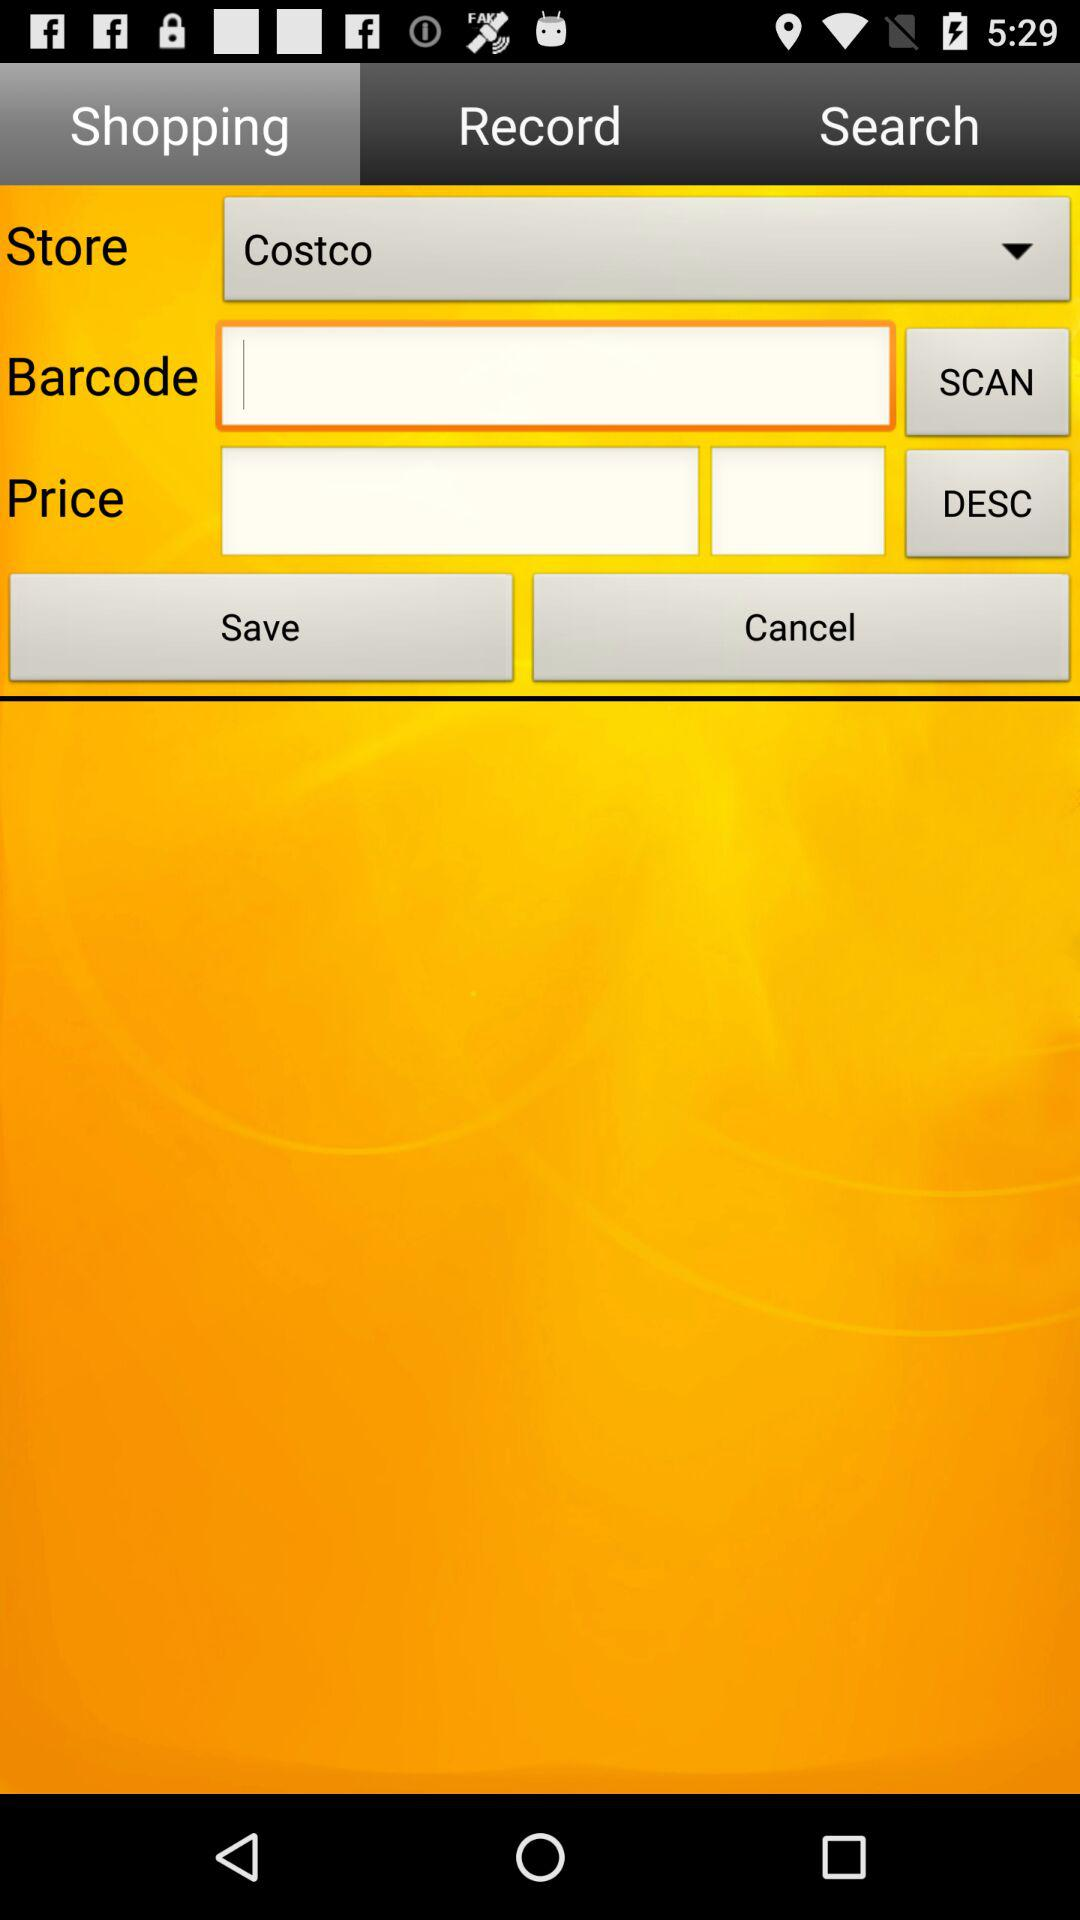Where is the store located?
When the provided information is insufficient, respond with <no answer>. <no answer> 